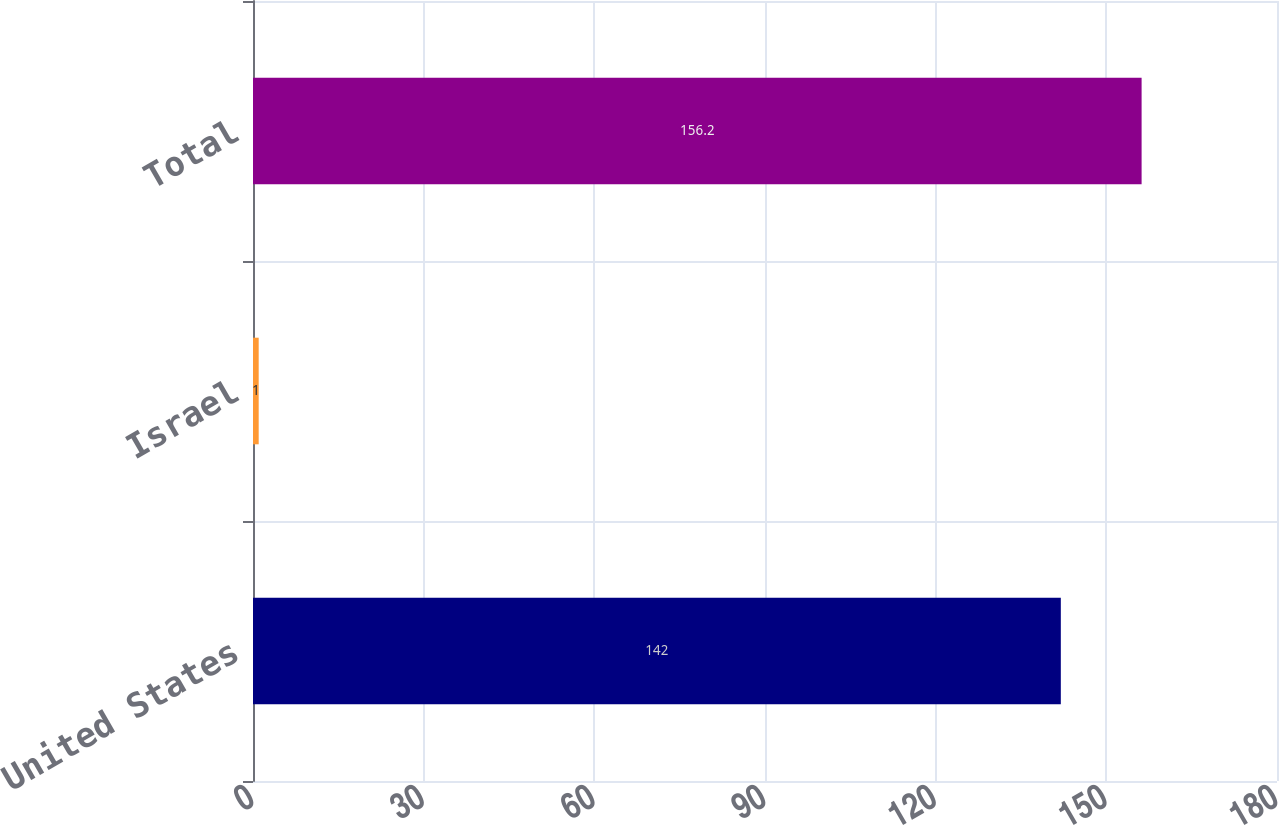Convert chart to OTSL. <chart><loc_0><loc_0><loc_500><loc_500><bar_chart><fcel>United States<fcel>Israel<fcel>Total<nl><fcel>142<fcel>1<fcel>156.2<nl></chart> 